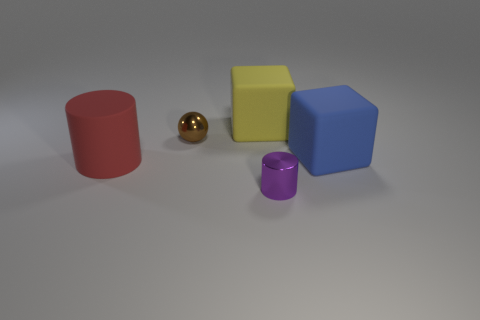What color is the cylinder that is the same material as the yellow thing?
Make the answer very short. Red. Is the color of the big matte cylinder the same as the tiny metallic ball?
Ensure brevity in your answer.  No. What is the large block that is right of the rubber object behind the small thing behind the purple thing made of?
Ensure brevity in your answer.  Rubber. There is a metallic object behind the red cylinder; does it have the same size as the blue cube?
Give a very brief answer. No. There is a block that is right of the big yellow cube; what is its material?
Offer a terse response. Rubber. Is the number of brown objects greater than the number of small things?
Provide a short and direct response. No. How many things are tiny brown metallic objects on the right side of the big red matte cylinder or big objects?
Your answer should be compact. 4. How many large yellow things are behind the cylinder to the left of the yellow matte thing?
Give a very brief answer. 1. What size is the matte object that is in front of the big cube that is right of the cylinder to the right of the yellow matte cube?
Provide a succinct answer. Large. There is a matte cylinder that is in front of the blue rubber cube; does it have the same color as the metal cylinder?
Give a very brief answer. No. 